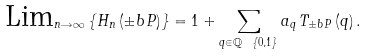<formula> <loc_0><loc_0><loc_500><loc_500>\text {Lim} _ { n \rightarrow \infty } \left \{ H _ { n } \left ( \pm b { P } \right ) \right \} = 1 + \sum _ { q \in \mathbb { Q } \ \left \{ 0 , 1 \right \} } a _ { q } \, T _ { \pm b { P } } \left ( q \right ) .</formula> 